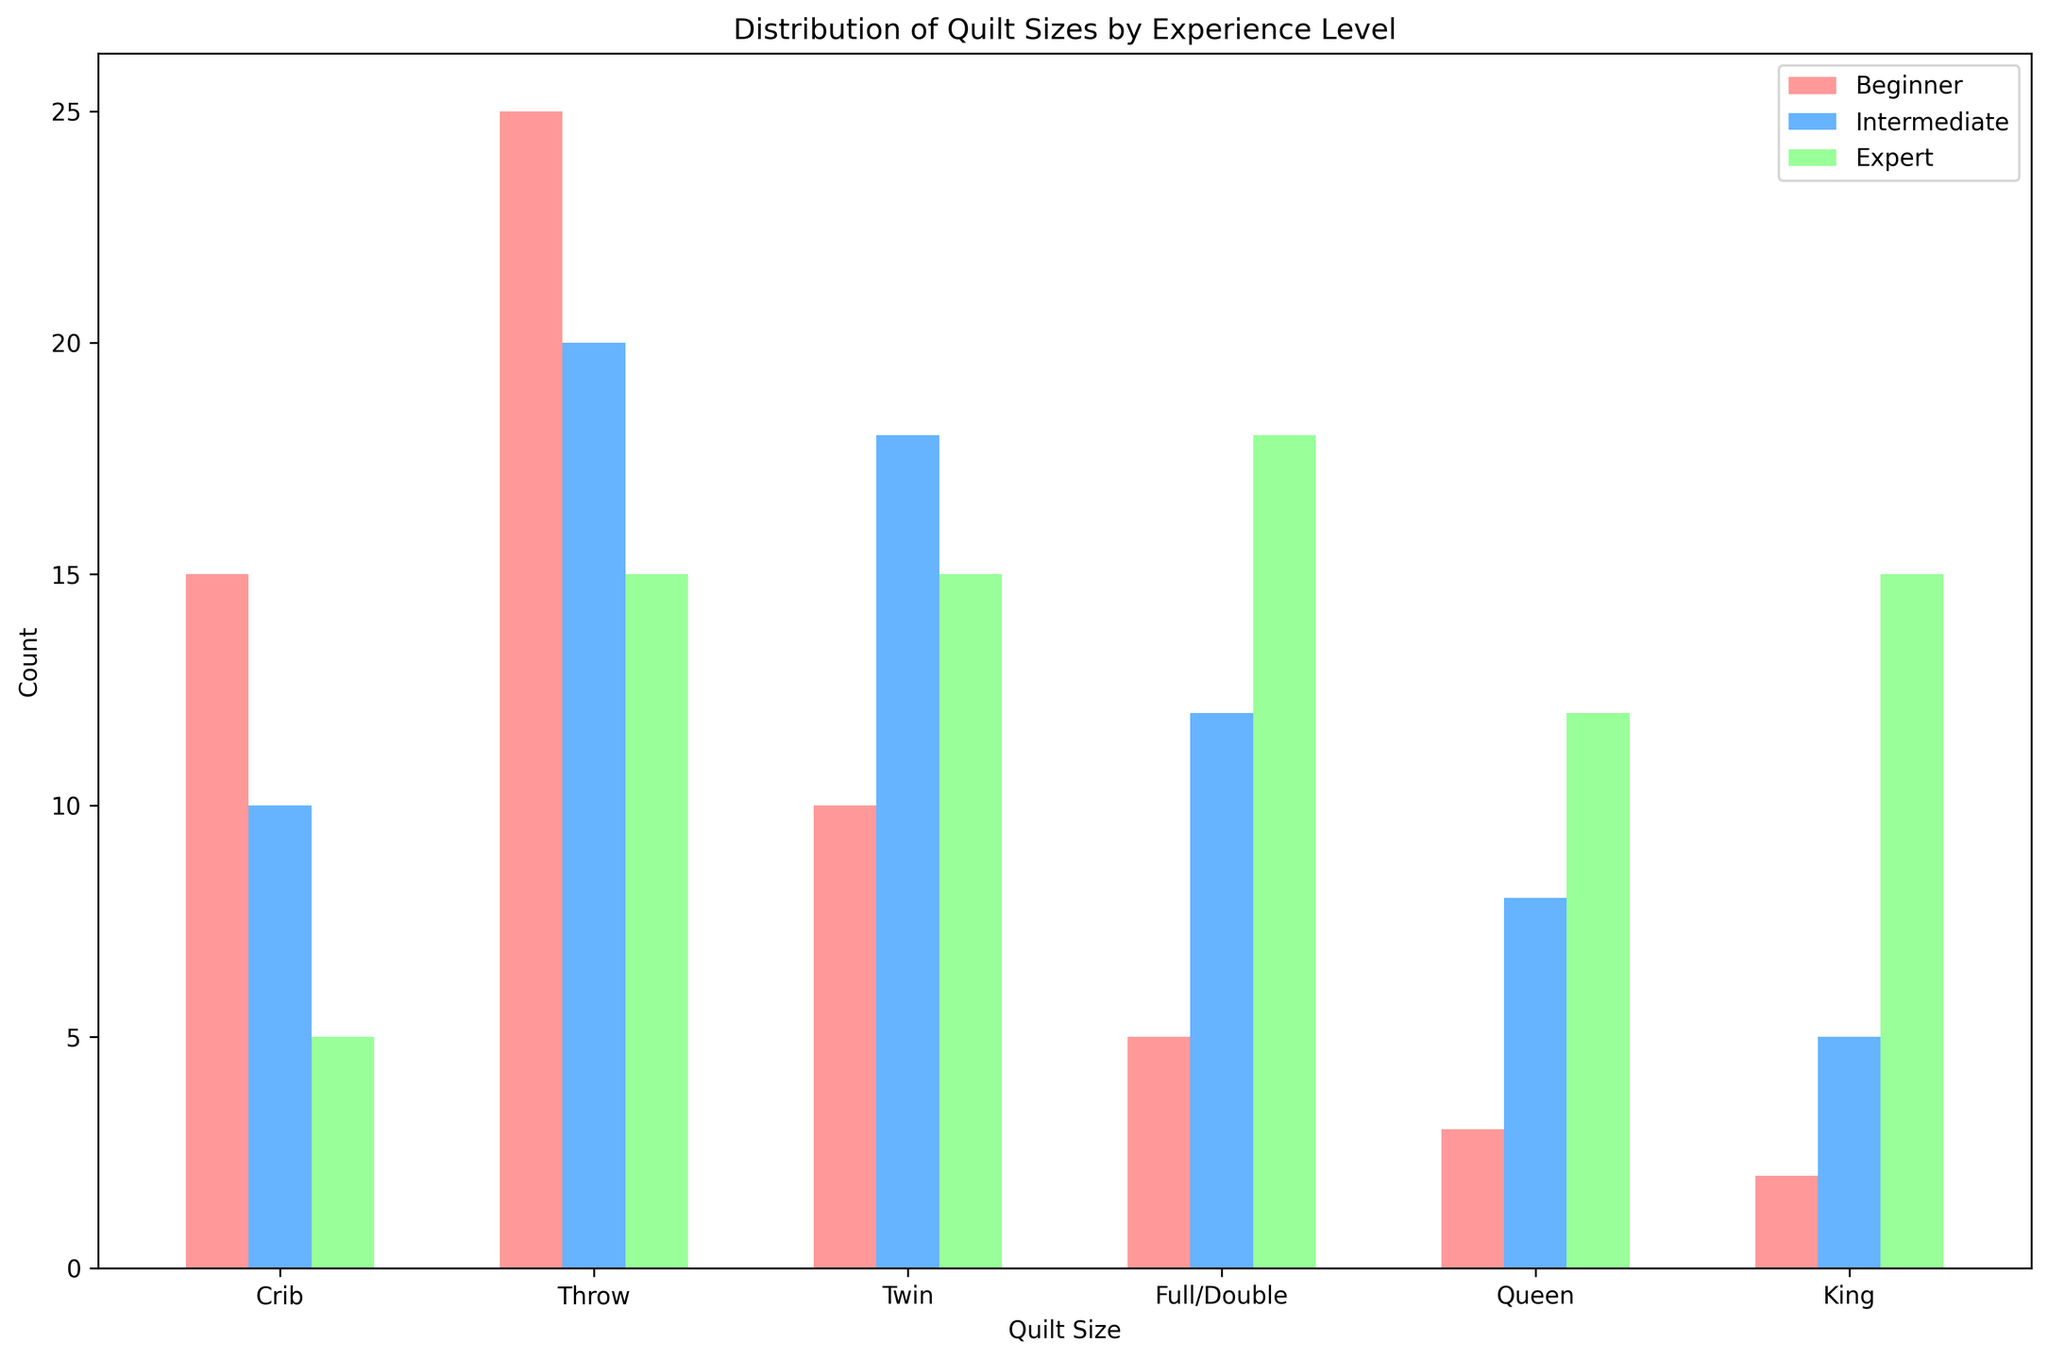What quilt size is most popular among beginner quilters? By looking at the height of the bars for beginners, the tallest bar indicates the most popular quilt size. For beginners, the "Throw" size has the highest count.
Answer: Throw Which experience level has the highest count of King-sized quilts? Compare the heights of the bars for the King size across all experience levels. The Expert level has the tallest bar for King-sized quilts.
Answer: Expert What is the total number of quilts made by intermediate quilters? Sum the counts for all quilt sizes under the Intermediate level: 10 (Crib) + 20 (Throw) + 18 (Twin) + 12 (Full/Double) + 8 (Queen) + 5 (King) = 73.
Answer: 73 How many more Full/Double-sized quilts have experts made compared to beginners? Subtract the count of Full/Double-sized quilts made by beginners from those made by experts: 18 (Expert) - 5 (Beginner) = 13.
Answer: 13 What is the average number of quilts made across all sizes by expert quilters? Calculate the sum of counts for all sizes by experts and then divide by the number of quilt sizes: (5 + 15 + 15 + 18 + 12 + 15) / 6 = 13.33.
Answer: 13.33 Which quilt size has the least variation in counts across different experience levels? The variation can be visually estimated by comparing the differences in bar heights across experience levels for each quilt size. Crib-sized quilts show the least variation between Beginner (15), Intermediate (10), and Expert (5).
Answer: Crib How many more Twin-sized quilts do intermediate quilters make compared to beginner quilters? Subtract the count of Twin-sized quilts made by beginners from those made by intermediates: 18 (Intermediate) - 10 (Beginner) = 8.
Answer: 8 Which experience level has the smallest variance in quilt counts across different sizes? To find the smallest variance, visually compare the consistency in bar heights across all quilt sizes for each experience level. Intermediate quilters have more uniform counts across sizes compared to the other levels.
Answer: Intermediate What is the range of counts for Queen-sized quilts across all experience levels? Identify the maximum and minimum counts for Queen-sized quilts and calculate the range: 12 (Expert) - 3 (Beginner) = 9.
Answer: 9 